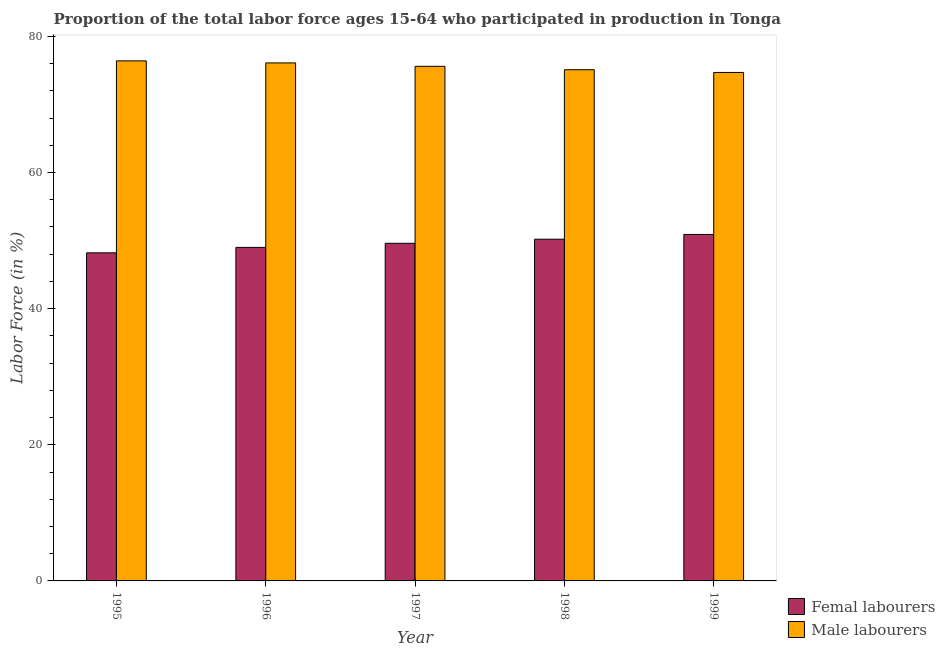Are the number of bars per tick equal to the number of legend labels?
Provide a succinct answer. Yes. How many bars are there on the 1st tick from the right?
Your answer should be compact. 2. What is the label of the 1st group of bars from the left?
Make the answer very short. 1995. What is the percentage of female labor force in 1999?
Make the answer very short. 50.9. Across all years, what is the maximum percentage of female labor force?
Offer a terse response. 50.9. Across all years, what is the minimum percentage of female labor force?
Ensure brevity in your answer.  48.2. What is the total percentage of male labour force in the graph?
Your answer should be compact. 377.9. What is the difference between the percentage of male labour force in 1995 and that in 1997?
Your answer should be very brief. 0.8. What is the difference between the percentage of female labor force in 1997 and the percentage of male labour force in 1995?
Keep it short and to the point. 1.4. What is the average percentage of male labour force per year?
Give a very brief answer. 75.58. In how many years, is the percentage of female labor force greater than 16 %?
Provide a short and direct response. 5. What is the ratio of the percentage of male labour force in 1997 to that in 1999?
Offer a very short reply. 1.01. Is the difference between the percentage of male labour force in 1995 and 1997 greater than the difference between the percentage of female labor force in 1995 and 1997?
Ensure brevity in your answer.  No. What is the difference between the highest and the second highest percentage of female labor force?
Offer a very short reply. 0.7. What is the difference between the highest and the lowest percentage of female labor force?
Provide a succinct answer. 2.7. What does the 2nd bar from the left in 1999 represents?
Offer a very short reply. Male labourers. What does the 2nd bar from the right in 1997 represents?
Your answer should be compact. Femal labourers. How many bars are there?
Ensure brevity in your answer.  10. Are all the bars in the graph horizontal?
Keep it short and to the point. No. How many years are there in the graph?
Provide a short and direct response. 5. What is the difference between two consecutive major ticks on the Y-axis?
Ensure brevity in your answer.  20. Does the graph contain any zero values?
Provide a succinct answer. No. Does the graph contain grids?
Your answer should be very brief. No. Where does the legend appear in the graph?
Offer a terse response. Bottom right. How are the legend labels stacked?
Your answer should be compact. Vertical. What is the title of the graph?
Offer a very short reply. Proportion of the total labor force ages 15-64 who participated in production in Tonga. What is the label or title of the X-axis?
Keep it short and to the point. Year. What is the Labor Force (in %) of Femal labourers in 1995?
Give a very brief answer. 48.2. What is the Labor Force (in %) in Male labourers in 1995?
Your response must be concise. 76.4. What is the Labor Force (in %) in Male labourers in 1996?
Your answer should be compact. 76.1. What is the Labor Force (in %) in Femal labourers in 1997?
Offer a terse response. 49.6. What is the Labor Force (in %) in Male labourers in 1997?
Your answer should be compact. 75.6. What is the Labor Force (in %) in Femal labourers in 1998?
Give a very brief answer. 50.2. What is the Labor Force (in %) in Male labourers in 1998?
Your response must be concise. 75.1. What is the Labor Force (in %) in Femal labourers in 1999?
Offer a very short reply. 50.9. What is the Labor Force (in %) of Male labourers in 1999?
Make the answer very short. 74.7. Across all years, what is the maximum Labor Force (in %) of Femal labourers?
Give a very brief answer. 50.9. Across all years, what is the maximum Labor Force (in %) in Male labourers?
Your answer should be compact. 76.4. Across all years, what is the minimum Labor Force (in %) in Femal labourers?
Your answer should be very brief. 48.2. Across all years, what is the minimum Labor Force (in %) of Male labourers?
Your answer should be very brief. 74.7. What is the total Labor Force (in %) in Femal labourers in the graph?
Keep it short and to the point. 247.9. What is the total Labor Force (in %) of Male labourers in the graph?
Provide a short and direct response. 377.9. What is the difference between the Labor Force (in %) of Femal labourers in 1995 and that in 1998?
Your answer should be compact. -2. What is the difference between the Labor Force (in %) in Male labourers in 1995 and that in 1999?
Ensure brevity in your answer.  1.7. What is the difference between the Labor Force (in %) in Femal labourers in 1996 and that in 1998?
Keep it short and to the point. -1.2. What is the difference between the Labor Force (in %) of Femal labourers in 1996 and that in 1999?
Provide a succinct answer. -1.9. What is the difference between the Labor Force (in %) in Male labourers in 1996 and that in 1999?
Make the answer very short. 1.4. What is the difference between the Labor Force (in %) in Male labourers in 1997 and that in 1998?
Ensure brevity in your answer.  0.5. What is the difference between the Labor Force (in %) of Femal labourers in 1997 and that in 1999?
Your response must be concise. -1.3. What is the difference between the Labor Force (in %) of Male labourers in 1997 and that in 1999?
Your answer should be very brief. 0.9. What is the difference between the Labor Force (in %) in Femal labourers in 1998 and that in 1999?
Ensure brevity in your answer.  -0.7. What is the difference between the Labor Force (in %) of Femal labourers in 1995 and the Labor Force (in %) of Male labourers in 1996?
Offer a terse response. -27.9. What is the difference between the Labor Force (in %) of Femal labourers in 1995 and the Labor Force (in %) of Male labourers in 1997?
Your answer should be very brief. -27.4. What is the difference between the Labor Force (in %) in Femal labourers in 1995 and the Labor Force (in %) in Male labourers in 1998?
Provide a succinct answer. -26.9. What is the difference between the Labor Force (in %) of Femal labourers in 1995 and the Labor Force (in %) of Male labourers in 1999?
Give a very brief answer. -26.5. What is the difference between the Labor Force (in %) of Femal labourers in 1996 and the Labor Force (in %) of Male labourers in 1997?
Provide a succinct answer. -26.6. What is the difference between the Labor Force (in %) in Femal labourers in 1996 and the Labor Force (in %) in Male labourers in 1998?
Offer a terse response. -26.1. What is the difference between the Labor Force (in %) in Femal labourers in 1996 and the Labor Force (in %) in Male labourers in 1999?
Give a very brief answer. -25.7. What is the difference between the Labor Force (in %) in Femal labourers in 1997 and the Labor Force (in %) in Male labourers in 1998?
Your answer should be very brief. -25.5. What is the difference between the Labor Force (in %) in Femal labourers in 1997 and the Labor Force (in %) in Male labourers in 1999?
Offer a very short reply. -25.1. What is the difference between the Labor Force (in %) in Femal labourers in 1998 and the Labor Force (in %) in Male labourers in 1999?
Make the answer very short. -24.5. What is the average Labor Force (in %) of Femal labourers per year?
Your answer should be compact. 49.58. What is the average Labor Force (in %) in Male labourers per year?
Give a very brief answer. 75.58. In the year 1995, what is the difference between the Labor Force (in %) of Femal labourers and Labor Force (in %) of Male labourers?
Your answer should be compact. -28.2. In the year 1996, what is the difference between the Labor Force (in %) in Femal labourers and Labor Force (in %) in Male labourers?
Provide a succinct answer. -27.1. In the year 1998, what is the difference between the Labor Force (in %) in Femal labourers and Labor Force (in %) in Male labourers?
Your response must be concise. -24.9. In the year 1999, what is the difference between the Labor Force (in %) of Femal labourers and Labor Force (in %) of Male labourers?
Give a very brief answer. -23.8. What is the ratio of the Labor Force (in %) of Femal labourers in 1995 to that in 1996?
Ensure brevity in your answer.  0.98. What is the ratio of the Labor Force (in %) in Femal labourers in 1995 to that in 1997?
Your answer should be compact. 0.97. What is the ratio of the Labor Force (in %) of Male labourers in 1995 to that in 1997?
Offer a very short reply. 1.01. What is the ratio of the Labor Force (in %) in Femal labourers in 1995 to that in 1998?
Give a very brief answer. 0.96. What is the ratio of the Labor Force (in %) of Male labourers in 1995 to that in 1998?
Your answer should be very brief. 1.02. What is the ratio of the Labor Force (in %) in Femal labourers in 1995 to that in 1999?
Make the answer very short. 0.95. What is the ratio of the Labor Force (in %) of Male labourers in 1995 to that in 1999?
Keep it short and to the point. 1.02. What is the ratio of the Labor Force (in %) in Femal labourers in 1996 to that in 1997?
Your answer should be very brief. 0.99. What is the ratio of the Labor Force (in %) of Male labourers in 1996 to that in 1997?
Ensure brevity in your answer.  1.01. What is the ratio of the Labor Force (in %) of Femal labourers in 1996 to that in 1998?
Keep it short and to the point. 0.98. What is the ratio of the Labor Force (in %) of Male labourers in 1996 to that in 1998?
Ensure brevity in your answer.  1.01. What is the ratio of the Labor Force (in %) of Femal labourers in 1996 to that in 1999?
Make the answer very short. 0.96. What is the ratio of the Labor Force (in %) in Male labourers in 1996 to that in 1999?
Give a very brief answer. 1.02. What is the ratio of the Labor Force (in %) of Femal labourers in 1997 to that in 1999?
Your answer should be very brief. 0.97. What is the ratio of the Labor Force (in %) in Male labourers in 1997 to that in 1999?
Give a very brief answer. 1.01. What is the ratio of the Labor Force (in %) of Femal labourers in 1998 to that in 1999?
Keep it short and to the point. 0.99. What is the ratio of the Labor Force (in %) of Male labourers in 1998 to that in 1999?
Offer a terse response. 1.01. What is the difference between the highest and the lowest Labor Force (in %) of Male labourers?
Your response must be concise. 1.7. 